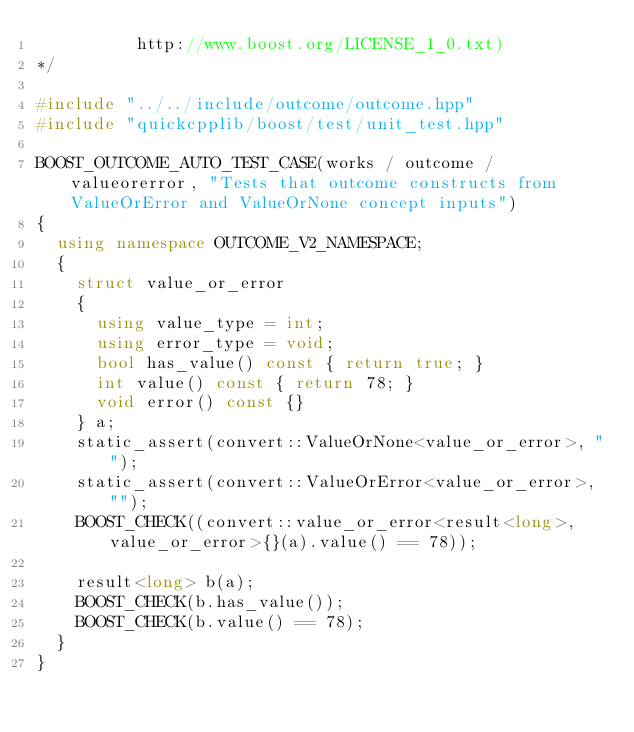<code> <loc_0><loc_0><loc_500><loc_500><_C++_>          http://www.boost.org/LICENSE_1_0.txt)
*/

#include "../../include/outcome/outcome.hpp"
#include "quickcpplib/boost/test/unit_test.hpp"

BOOST_OUTCOME_AUTO_TEST_CASE(works / outcome / valueorerror, "Tests that outcome constructs from ValueOrError and ValueOrNone concept inputs")
{
  using namespace OUTCOME_V2_NAMESPACE;
  {
    struct value_or_error
    {
      using value_type = int;
      using error_type = void;
      bool has_value() const { return true; }
      int value() const { return 78; }
      void error() const {}
    } a;
    static_assert(convert::ValueOrNone<value_or_error>, "");
    static_assert(convert::ValueOrError<value_or_error>, "");
    BOOST_CHECK((convert::value_or_error<result<long>, value_or_error>{}(a).value() == 78));

    result<long> b(a);
    BOOST_CHECK(b.has_value());
    BOOST_CHECK(b.value() == 78);
  }
}
</code> 